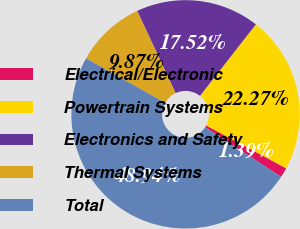Convert chart. <chart><loc_0><loc_0><loc_500><loc_500><pie_chart><fcel>Electrical/Electronic<fcel>Powertrain Systems<fcel>Electronics and Safety<fcel>Thermal Systems<fcel>Total<nl><fcel>1.39%<fcel>22.27%<fcel>17.52%<fcel>9.87%<fcel>48.94%<nl></chart> 